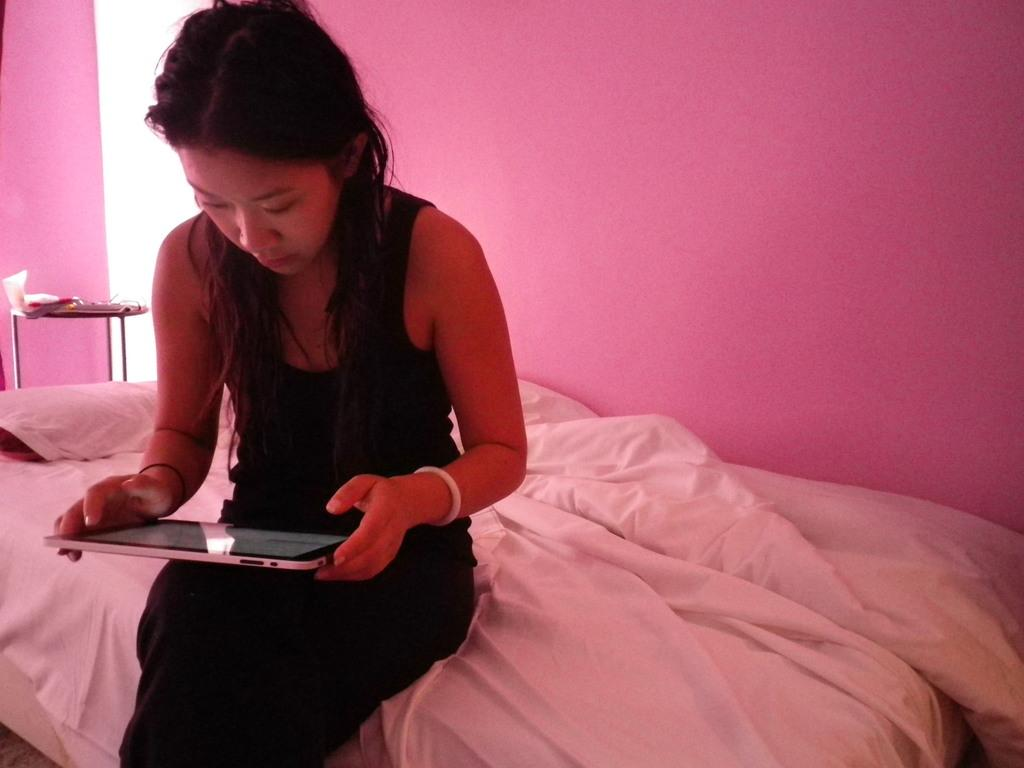What is the woman in the image doing? The woman is seated in the image. What object is the woman holding in her hand? The woman is holding an iPad in her hand. What type of furniture is present in the image? There is a bed and a pillow in the image. What holiday is the woman celebrating in the image? There is no indication of a holiday in the image. Can you tell me how many times the woman turns around in the image? The woman does not turn around in the image; she is seated with an iPad in her hand. 